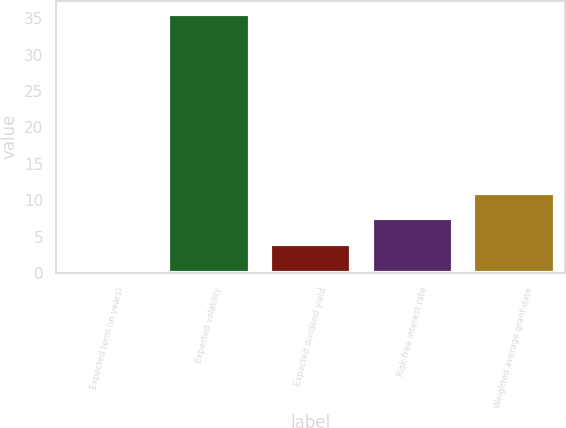Convert chart to OTSL. <chart><loc_0><loc_0><loc_500><loc_500><bar_chart><fcel>Expected term (in years)<fcel>Expected volatility<fcel>Expected dividend yield<fcel>Risk-free interest rate<fcel>Weighted average grant-date<nl><fcel>0.5<fcel>35.65<fcel>4.02<fcel>7.54<fcel>11.05<nl></chart> 